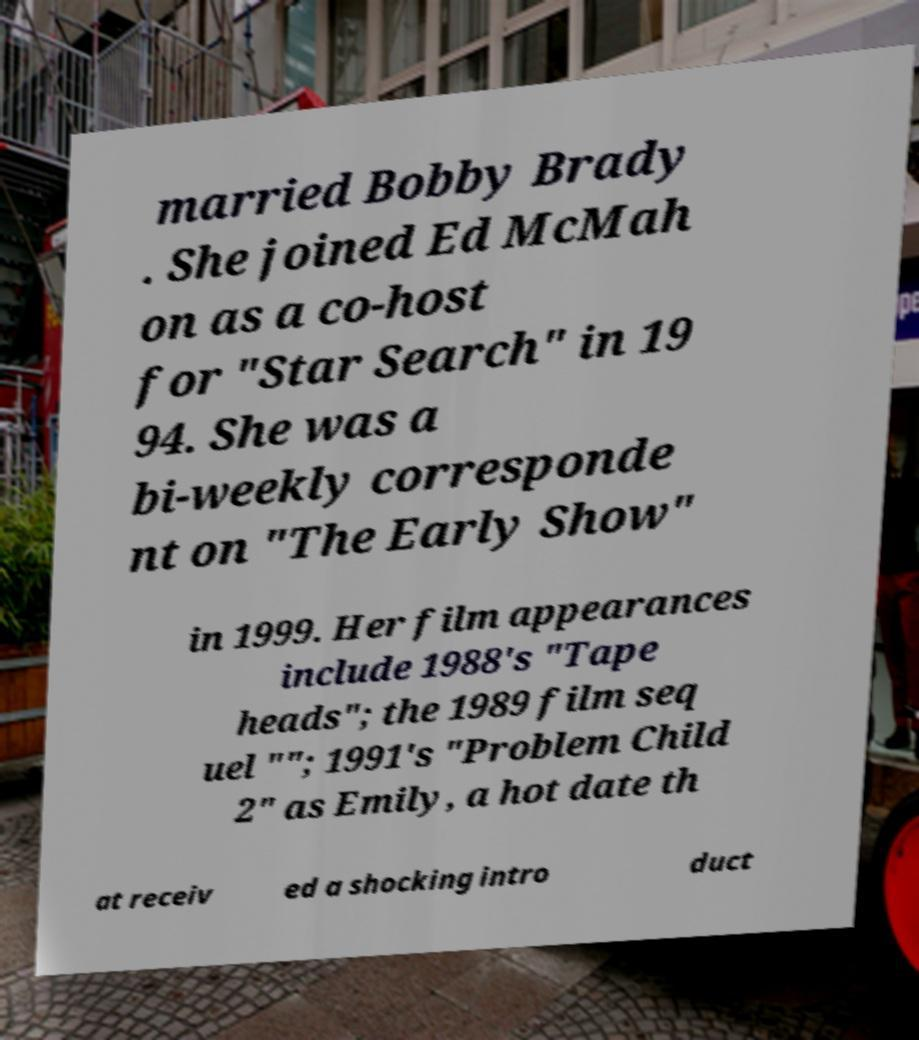Can you accurately transcribe the text from the provided image for me? married Bobby Brady . She joined Ed McMah on as a co-host for "Star Search" in 19 94. She was a bi-weekly corresponde nt on "The Early Show" in 1999. Her film appearances include 1988's "Tape heads"; the 1989 film seq uel ""; 1991's "Problem Child 2" as Emily, a hot date th at receiv ed a shocking intro duct 